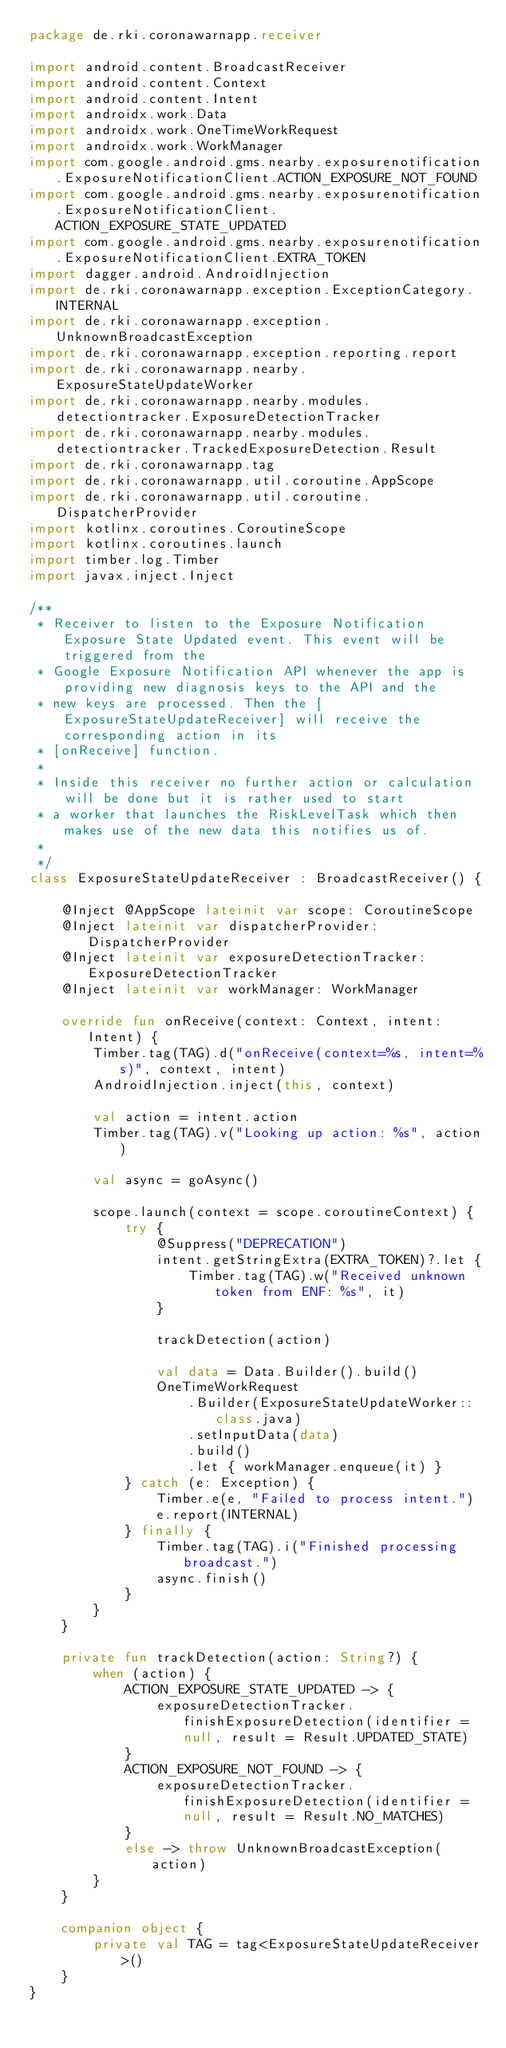<code> <loc_0><loc_0><loc_500><loc_500><_Kotlin_>package de.rki.coronawarnapp.receiver

import android.content.BroadcastReceiver
import android.content.Context
import android.content.Intent
import androidx.work.Data
import androidx.work.OneTimeWorkRequest
import androidx.work.WorkManager
import com.google.android.gms.nearby.exposurenotification.ExposureNotificationClient.ACTION_EXPOSURE_NOT_FOUND
import com.google.android.gms.nearby.exposurenotification.ExposureNotificationClient.ACTION_EXPOSURE_STATE_UPDATED
import com.google.android.gms.nearby.exposurenotification.ExposureNotificationClient.EXTRA_TOKEN
import dagger.android.AndroidInjection
import de.rki.coronawarnapp.exception.ExceptionCategory.INTERNAL
import de.rki.coronawarnapp.exception.UnknownBroadcastException
import de.rki.coronawarnapp.exception.reporting.report
import de.rki.coronawarnapp.nearby.ExposureStateUpdateWorker
import de.rki.coronawarnapp.nearby.modules.detectiontracker.ExposureDetectionTracker
import de.rki.coronawarnapp.nearby.modules.detectiontracker.TrackedExposureDetection.Result
import de.rki.coronawarnapp.tag
import de.rki.coronawarnapp.util.coroutine.AppScope
import de.rki.coronawarnapp.util.coroutine.DispatcherProvider
import kotlinx.coroutines.CoroutineScope
import kotlinx.coroutines.launch
import timber.log.Timber
import javax.inject.Inject

/**
 * Receiver to listen to the Exposure Notification Exposure State Updated event. This event will be triggered from the
 * Google Exposure Notification API whenever the app is providing new diagnosis keys to the API and the
 * new keys are processed. Then the [ExposureStateUpdateReceiver] will receive the corresponding action in its
 * [onReceive] function.
 *
 * Inside this receiver no further action or calculation will be done but it is rather used to start
 * a worker that launches the RiskLevelTask which then makes use of the new data this notifies us of.
 *
 */
class ExposureStateUpdateReceiver : BroadcastReceiver() {

    @Inject @AppScope lateinit var scope: CoroutineScope
    @Inject lateinit var dispatcherProvider: DispatcherProvider
    @Inject lateinit var exposureDetectionTracker: ExposureDetectionTracker
    @Inject lateinit var workManager: WorkManager

    override fun onReceive(context: Context, intent: Intent) {
        Timber.tag(TAG).d("onReceive(context=%s, intent=%s)", context, intent)
        AndroidInjection.inject(this, context)

        val action = intent.action
        Timber.tag(TAG).v("Looking up action: %s", action)

        val async = goAsync()

        scope.launch(context = scope.coroutineContext) {
            try {
                @Suppress("DEPRECATION")
                intent.getStringExtra(EXTRA_TOKEN)?.let {
                    Timber.tag(TAG).w("Received unknown token from ENF: %s", it)
                }

                trackDetection(action)

                val data = Data.Builder().build()
                OneTimeWorkRequest
                    .Builder(ExposureStateUpdateWorker::class.java)
                    .setInputData(data)
                    .build()
                    .let { workManager.enqueue(it) }
            } catch (e: Exception) {
                Timber.e(e, "Failed to process intent.")
                e.report(INTERNAL)
            } finally {
                Timber.tag(TAG).i("Finished processing broadcast.")
                async.finish()
            }
        }
    }

    private fun trackDetection(action: String?) {
        when (action) {
            ACTION_EXPOSURE_STATE_UPDATED -> {
                exposureDetectionTracker.finishExposureDetection(identifier = null, result = Result.UPDATED_STATE)
            }
            ACTION_EXPOSURE_NOT_FOUND -> {
                exposureDetectionTracker.finishExposureDetection(identifier = null, result = Result.NO_MATCHES)
            }
            else -> throw UnknownBroadcastException(action)
        }
    }

    companion object {
        private val TAG = tag<ExposureStateUpdateReceiver>()
    }
}
</code> 